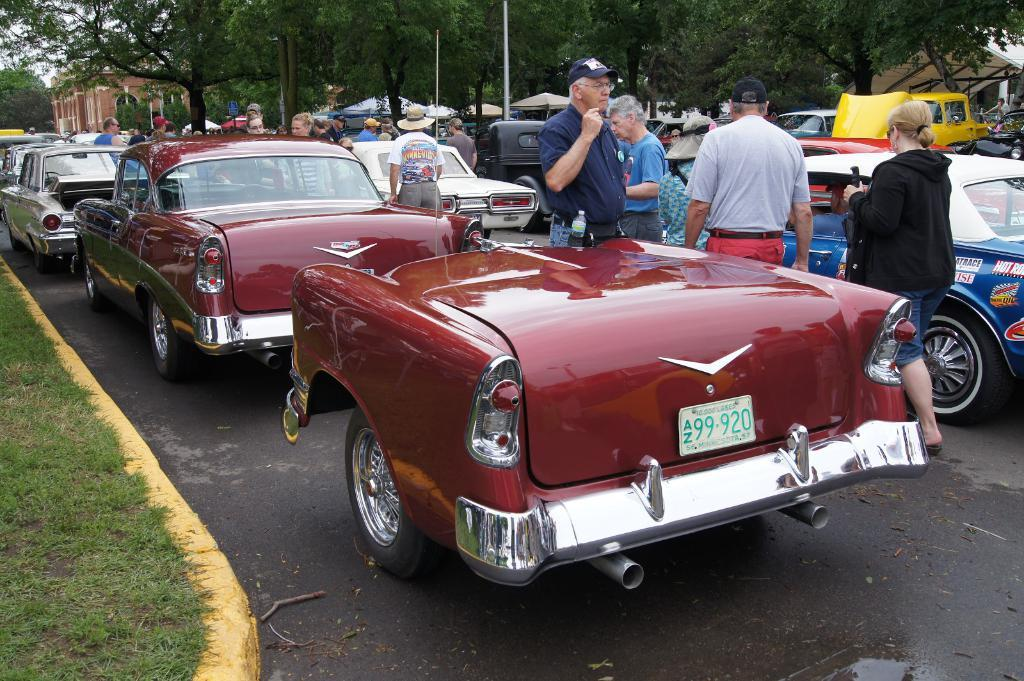What can be seen on the road in the image? There are vehicles and persons on the road in the image. What type of vegetation is visible in the image? There is grass visible in the image. What can be seen in the background of the image? There are trees, poles, buildings, and the sky visible in the background of the image. Where is the robin sitting in the image? There is no robin present in the image. What type of place is depicted in the image? The image does not depict a specific place; it shows a road with vehicles and persons, surrounded by trees, poles, buildings, and the sky. 